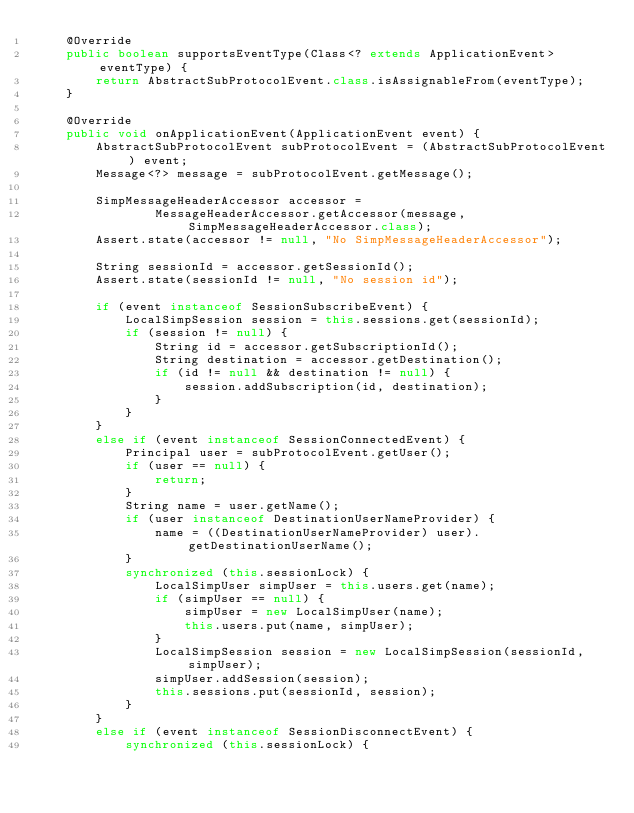Convert code to text. <code><loc_0><loc_0><loc_500><loc_500><_Java_>	@Override
	public boolean supportsEventType(Class<? extends ApplicationEvent> eventType) {
		return AbstractSubProtocolEvent.class.isAssignableFrom(eventType);
	}

	@Override
	public void onApplicationEvent(ApplicationEvent event) {
		AbstractSubProtocolEvent subProtocolEvent = (AbstractSubProtocolEvent) event;
		Message<?> message = subProtocolEvent.getMessage();

		SimpMessageHeaderAccessor accessor =
				MessageHeaderAccessor.getAccessor(message, SimpMessageHeaderAccessor.class);
		Assert.state(accessor != null, "No SimpMessageHeaderAccessor");

		String sessionId = accessor.getSessionId();
		Assert.state(sessionId != null, "No session id");

		if (event instanceof SessionSubscribeEvent) {
			LocalSimpSession session = this.sessions.get(sessionId);
			if (session != null) {
				String id = accessor.getSubscriptionId();
				String destination = accessor.getDestination();
				if (id != null && destination != null) {
					session.addSubscription(id, destination);
				}
			}
		}
		else if (event instanceof SessionConnectedEvent) {
			Principal user = subProtocolEvent.getUser();
			if (user == null) {
				return;
			}
			String name = user.getName();
			if (user instanceof DestinationUserNameProvider) {
				name = ((DestinationUserNameProvider) user).getDestinationUserName();
			}
			synchronized (this.sessionLock) {
				LocalSimpUser simpUser = this.users.get(name);
				if (simpUser == null) {
					simpUser = new LocalSimpUser(name);
					this.users.put(name, simpUser);
				}
				LocalSimpSession session = new LocalSimpSession(sessionId, simpUser);
				simpUser.addSession(session);
				this.sessions.put(sessionId, session);
			}
		}
		else if (event instanceof SessionDisconnectEvent) {
			synchronized (this.sessionLock) {</code> 